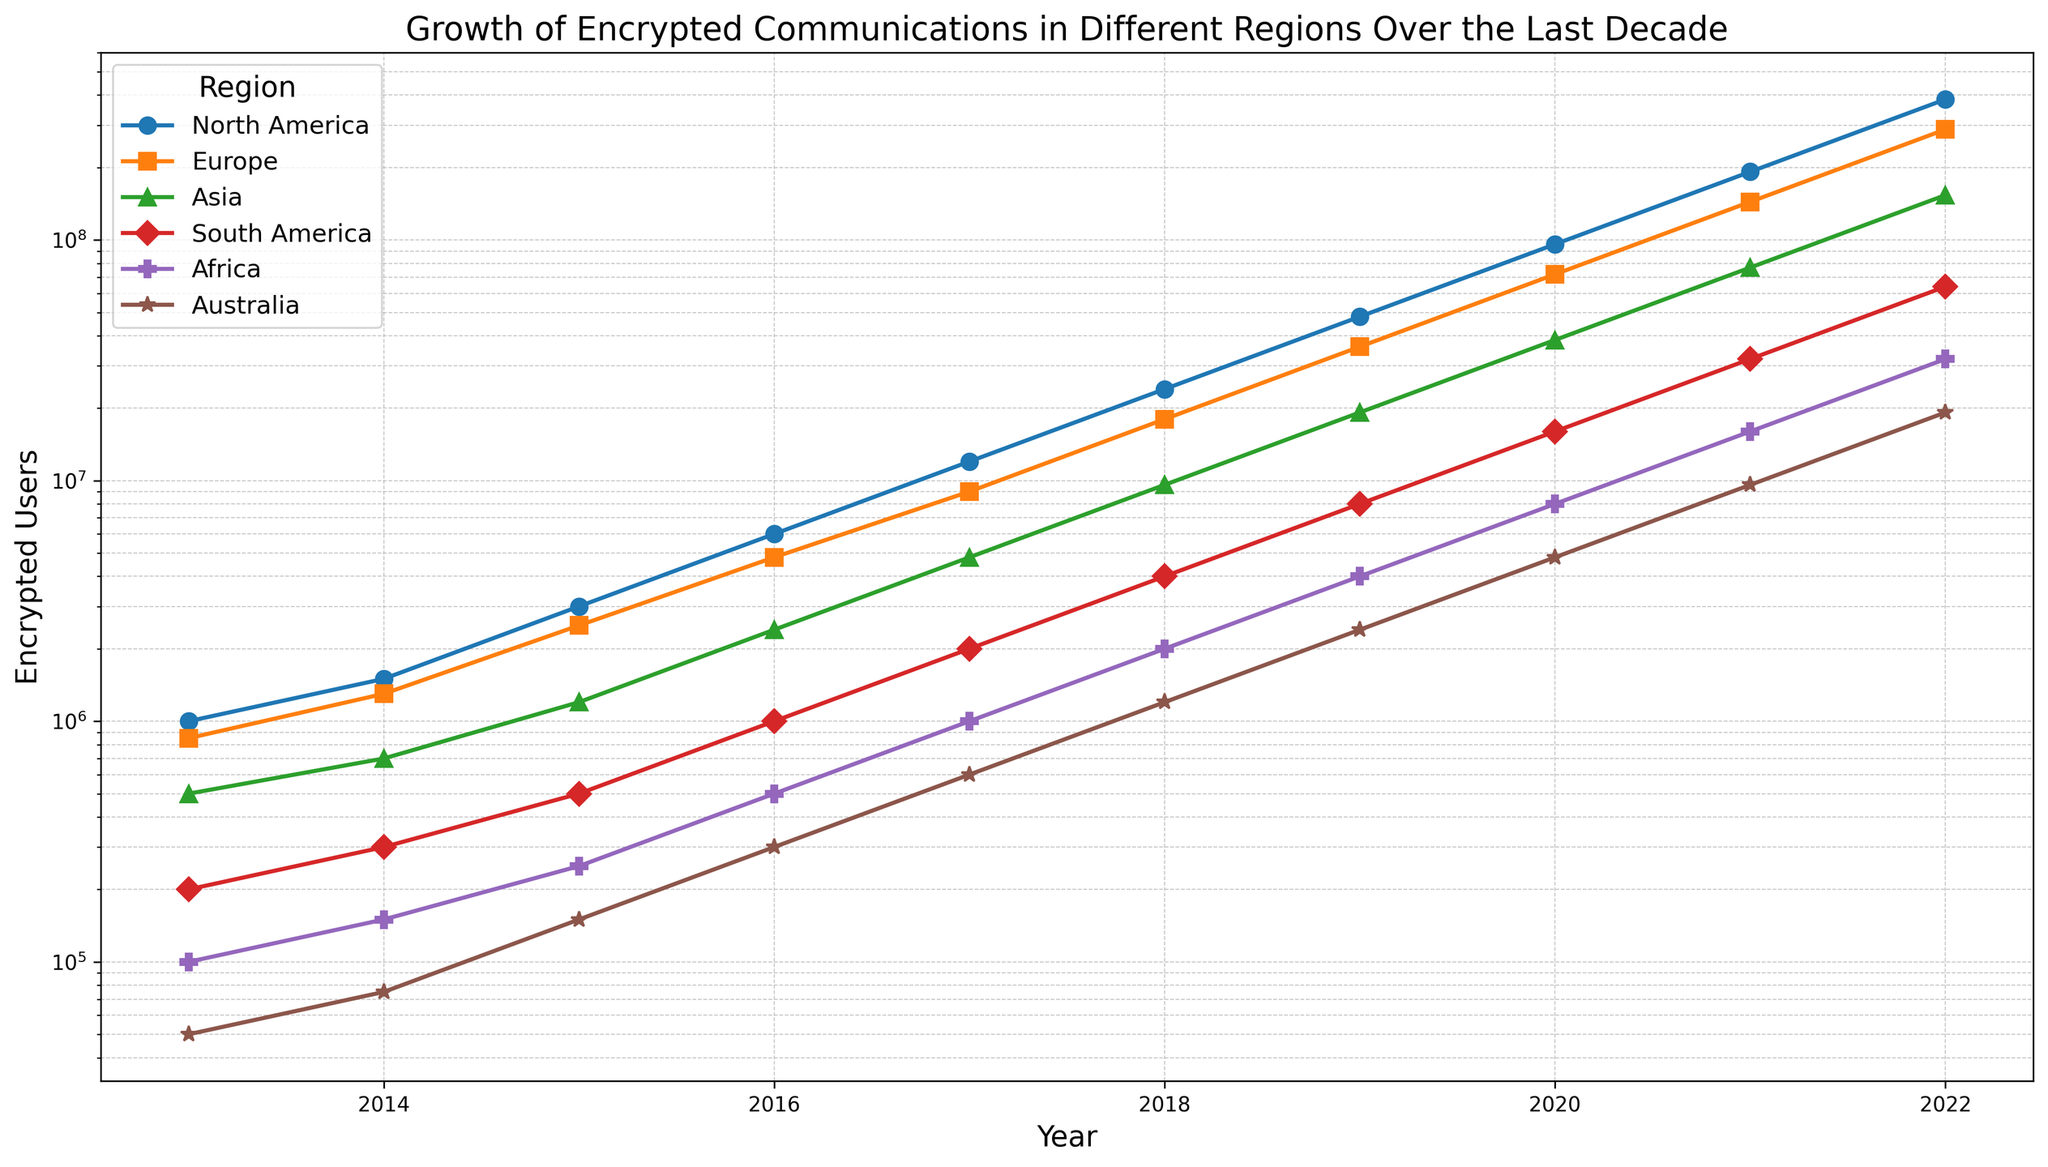Which region had the highest number of encrypted users in 2022? The figure shows that North America had the highest number of encrypted users in 2022, with the blue line being the highest on the y-axis for that year.
Answer: North America Compare the exponential growth rates: Which region showed the steepest increase in encrypted users between 2013 and 2022? By visually examining the slopes of the lines, North America shows the steepest increase, indicating the highest exponential growth rate over the period.
Answer: North America Between which years did Europe see the largest increase in the number of encrypted users? The orange line representing Europe shows the largest vertical jump between 2020 and 2021.
Answer: 2020 to 2021 Which region had the lowest number of encrypted users in 2015? The plot shows that Australia, indicated by the brown line, had the lowest number of encrypted users in 2015 with only 150,000 users.
Answer: Australia How did the number of encrypted users in Africa change from 2015 to 2018? The purple line representing Africa shows an increase from 250,000 to 2,000,000 users during that period. This is an eightfold increase.
Answer: Increased by 1,750,000 By how much did the number of encrypted users in South America increase between 2017 and 2019? Based on the position of the red line, the number of users increased from 2,000,000 in 2017 to 8,000,000 in 2019. The difference is 8,000,000 - 2,000,000 = 6,000,000.
Answer: Increased by 6,000,000 Which two regions had similar numbers of encrypted users in 2020? From the figure, Africa and Australia show similar numbers of encrypted users in 2020, around 8,000,000 and 4,800,000 respectively.
Answer: Africa and Australia What is the average number of encrypted users across all regions in 2016? Summing up the values for 2016 across all regions: 6,000,000 (NA) + 4,800,000 (Europe) + 2,400,000 (Asia) + 1,000,000 (SA) + 500,000 (Africa) + 300,000 (Australia) = 15,000,000. The average is 15,000,000 / 6 = 2,500,000.
Answer: 2,500,000 By what factor did the number of encrypted users in Asia multiply from 2013 to 2022? Asia (green line) grew from 500,000 to 153,600,000 users. The multiplication factor is 153,600,000 / 500,000 = 307.2.
Answer: 307.2 